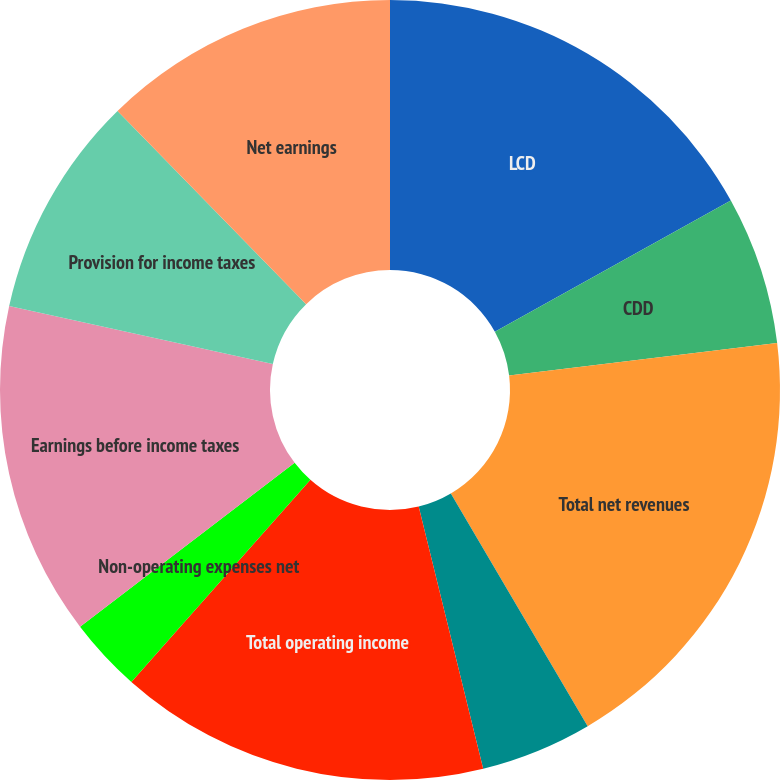<chart> <loc_0><loc_0><loc_500><loc_500><pie_chart><fcel>LCD<fcel>CDD<fcel>Total net revenues<fcel>General corporate expenses<fcel>Total operating income<fcel>Non-operating expenses net<fcel>Earnings before income taxes<fcel>Provision for income taxes<fcel>Net earnings<fcel>Less Net income attributable<nl><fcel>16.92%<fcel>6.16%<fcel>18.46%<fcel>4.62%<fcel>15.38%<fcel>3.08%<fcel>13.84%<fcel>9.23%<fcel>12.31%<fcel>0.0%<nl></chart> 